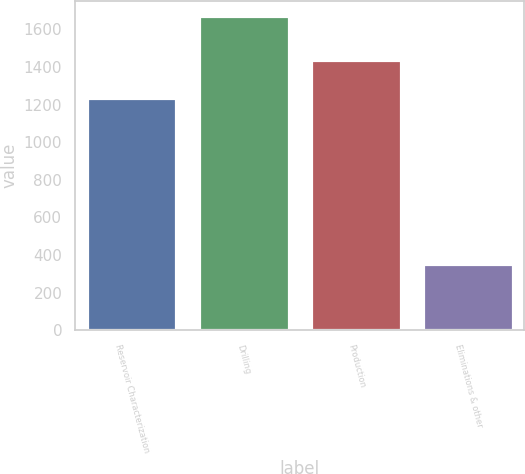Convert chart to OTSL. <chart><loc_0><loc_0><loc_500><loc_500><bar_chart><fcel>Reservoir Characterization<fcel>Drilling<fcel>Production<fcel>Eliminations & other<nl><fcel>1235<fcel>1668<fcel>1439<fcel>352<nl></chart> 